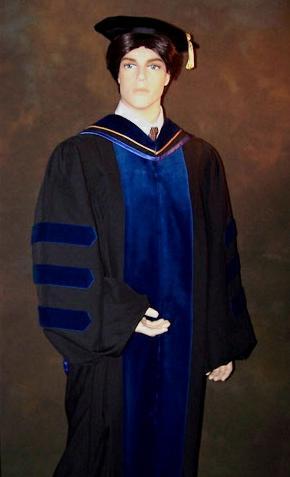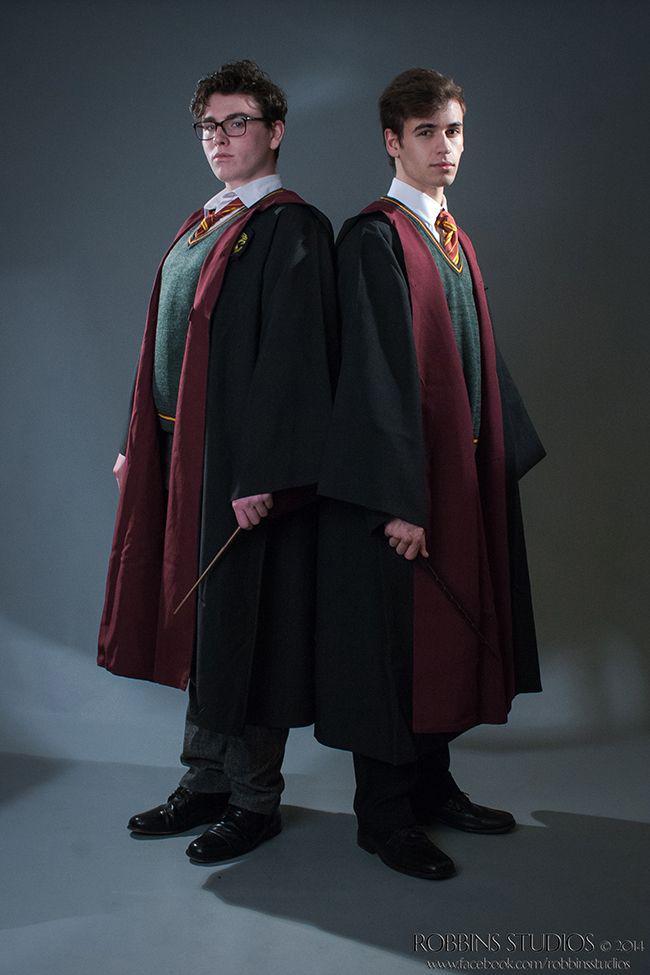The first image is the image on the left, the second image is the image on the right. Analyze the images presented: Is the assertion "There is one an wearing a graduation gown" valid? Answer yes or no. No. The first image is the image on the left, the second image is the image on the right. For the images displayed, is the sentence "One image contains at least one living young male model." factually correct? Answer yes or no. Yes. 